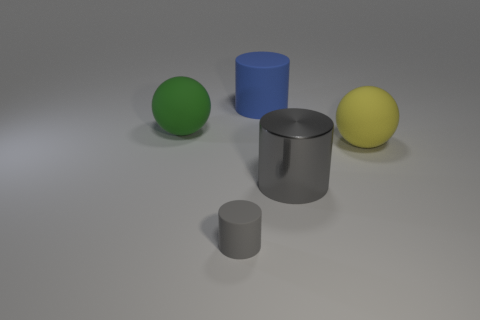What materials do the objects in the image appear to be made from? The objects in the image seem to be made from different materials based on their surfaces. The green and yellow spheres have a smooth, possibly plastic or rubber texture. The larger yellow sphere also seems matte, perhaps a painted surface, while the blue and grey cylinders appear to have a matte metal finish. 